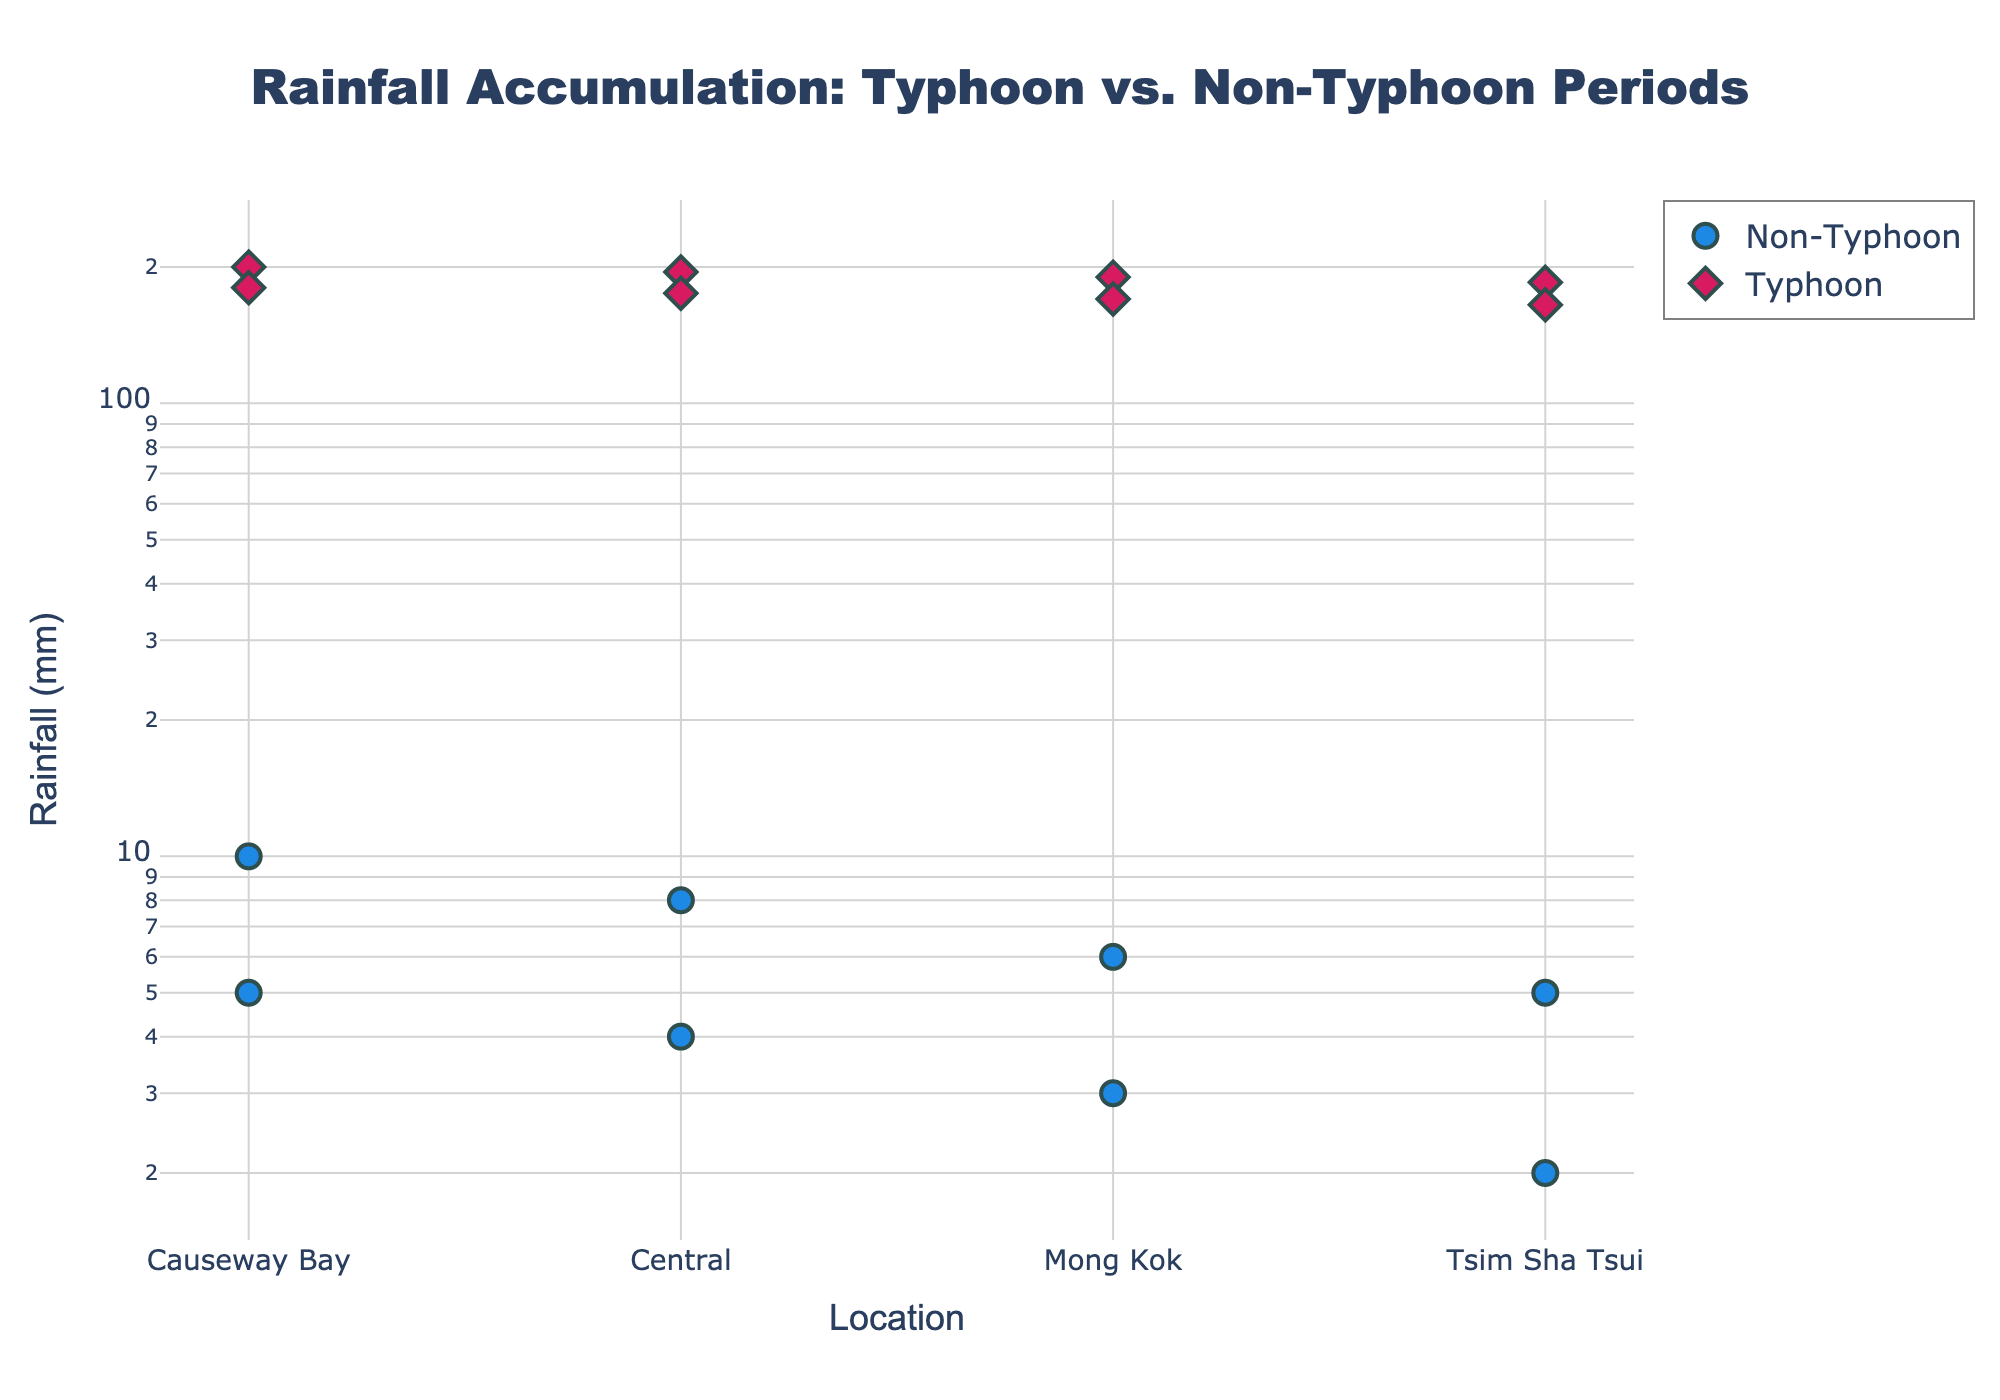What's the title of the plot? The title of the plot is located at the top and it summarizes the entire figure's purpose.
Answer: Rainfall Accumulation: Typhoon vs. Non-Typhoon Periods What are the colors used to distinguish typhoon and non-typhoon periods? The visual appearance shows distinct colors for different periods: blue for non-typhoon and red for typhoon periods.
Answer: Blue and Red Which location recorded the highest rainfall during a typhoon period? By examining the y-axis values for 'Typhoon' markers, the highest rainfall is at Causeway Bay with 200 mm.
Answer: Causeway Bay How do the rainfall amounts during typhoon periods compare with non-typhoon periods at Mong Kok? Compare the markers for Mong Kok in both periods. During typhoon periods, Mong Kok has around 170-190 mm rainfall, significantly higher than 3-6 mm during non-typhoon periods.
Answer: Typhoon periods have much higher rainfall What is the median rainfall accumulation during typhoon periods? The typhoon periods have four data points: (165, 170, 175, 180, 185, 190, 195, 200). The median is the average of the fourth and fifth values (both calculated as 180 + 185) / 2 = 182.5 mm.
Answer: 182.5 mm Which period shows the larger spread in rainfall values among the locations? For each period, check the difference between the highest and lowest rainfall values: Non-typhoon (10-2=8 mm) and Typhoon (200-165=35 mm). Typhoon periods show the larger spread.
Answer: Typhoon What type of scale is used on the y-axis? The y-axis values are positioned with increasing distances, not linearly, which indicates the use of a log scale.
Answer: Log scale Which period had a greater average rainfall and by how much? Calculate the average for each period: Non-typhoon (average=(5+4+3+2+10+8+6+5)/8=5.375 mm), Typhoon (average=(200+195+190+185+180+175+170+165)/8=182.5 mm). The difference is 182.5 - 5.375 = 177.125 mm.
Answer: Typhoon by 177.125 mm What can be inferred about the frequency of high rainfall events between the two periods? Logarithmic y-axis makes the differences clear: all typhoon period values are much higher, indicating such high rainfall events only occur during typhoon periods.
Answer: High rainfall events are tied to typhoon periods Which location had the most consistent rainfall across both periods? Analyze each location across periods: Causeway Bay (5 vs. 200, 10 vs. 180), Central (4 vs. 195, 8 vs. 175), Mong Kok (3 vs. 190, 6 vs. 170), Tsim Sha Tsui (2 vs. 185, 5 vs. 165). Since all values differ greatly, none are very consistent.
Answer: None 